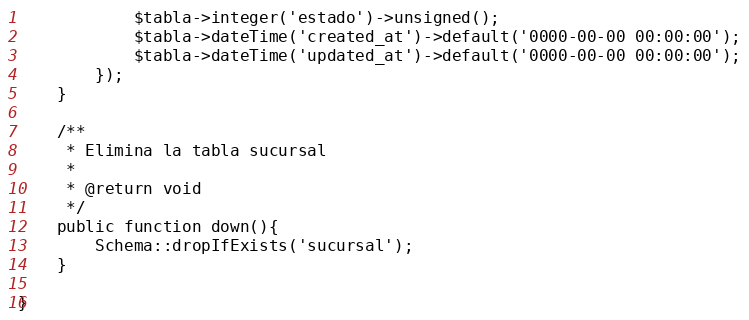Convert code to text. <code><loc_0><loc_0><loc_500><loc_500><_PHP_>			$tabla->integer('estado')->unsigned();
			$tabla->dateTime('created_at')->default('0000-00-00 00:00:00');
			$tabla->dateTime('updated_at')->default('0000-00-00 00:00:00');
		});
	}

	/**
	 * Elimina la tabla sucursal
	 *
	 * @return void
	 */
	public function down(){
		Schema::dropIfExists('sucursal');
	}

}
</code> 